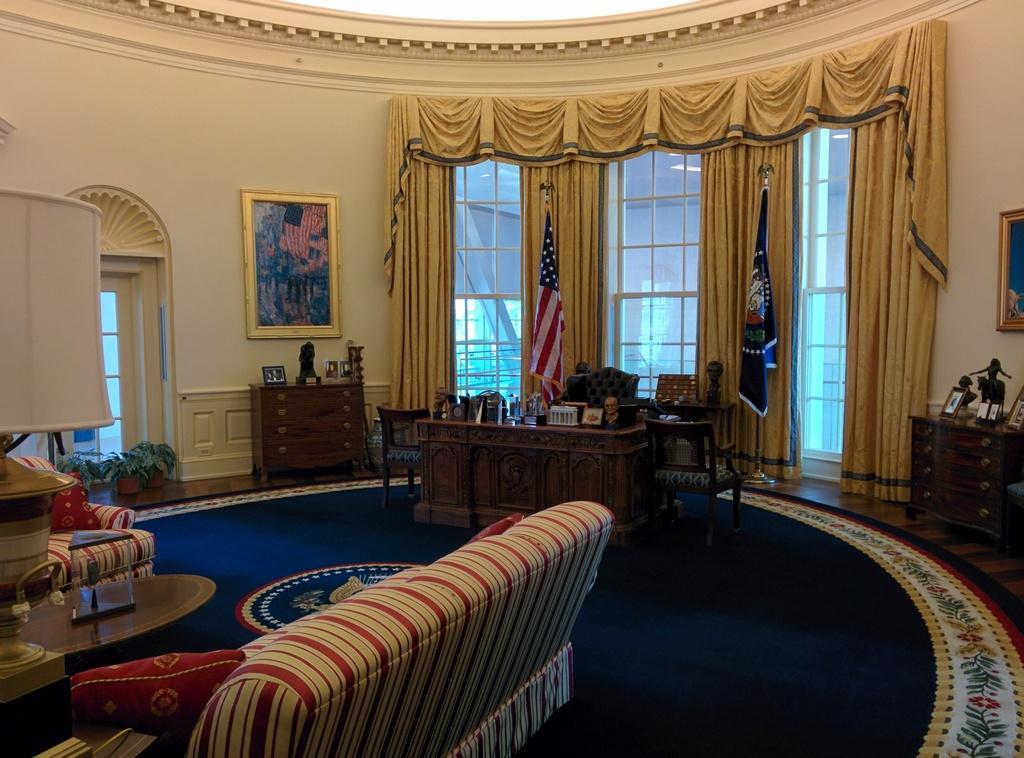Could you give a brief overview of what you see in this image? In this picture there is a sofa. In front of the sofa there is a table. We can observe a desk on which some accessories were placed on either side of the desk. There are some chairs here. In the background there are two countries flags. We can observe some curtains and windows here there is a photo frame attached to the wall here. 